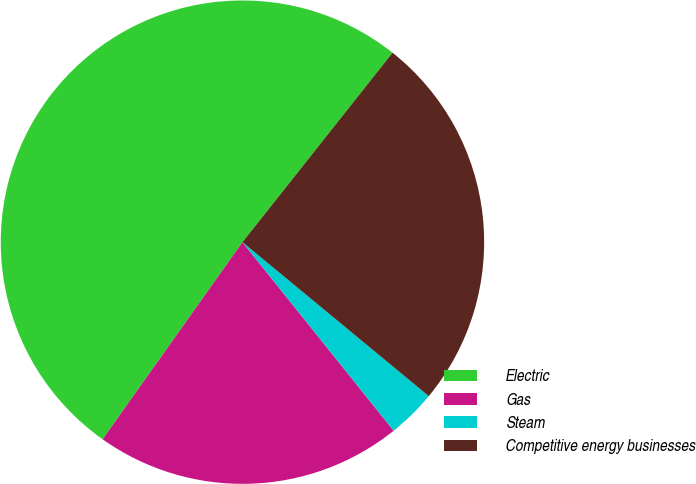<chart> <loc_0><loc_0><loc_500><loc_500><pie_chart><fcel>Electric<fcel>Gas<fcel>Steam<fcel>Competitive energy businesses<nl><fcel>50.84%<fcel>20.58%<fcel>3.25%<fcel>25.33%<nl></chart> 